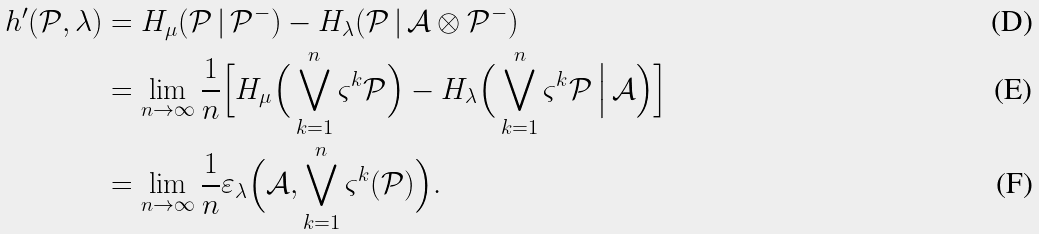<formula> <loc_0><loc_0><loc_500><loc_500>h ^ { \prime } ( \mathcal { P } , \lambda ) & = H _ { \mu } ( \mathcal { P } \, | \, \mathcal { P } ^ { - } ) - H _ { \lambda } ( \mathcal { P } \, | \, \mathcal { A } \otimes \mathcal { P } ^ { - } ) \\ & = \lim _ { n \to \infty } \frac { 1 } { n } \Big [ H _ { \mu } \Big ( \bigvee _ { k = 1 } ^ { n } \varsigma ^ { k } \mathcal { P } \Big ) - H _ { \lambda } \Big ( \bigvee _ { k = 1 } ^ { n } \varsigma ^ { k } \mathcal { P } \, \Big | \, \mathcal { A } \Big ) \Big ] \\ & = \lim _ { n \to \infty } \frac { 1 } { n } \varepsilon _ { \lambda } \Big ( \mathcal { A } , \bigvee _ { k = 1 } ^ { n } \varsigma ^ { k } ( \mathcal { P } ) \Big ) .</formula> 